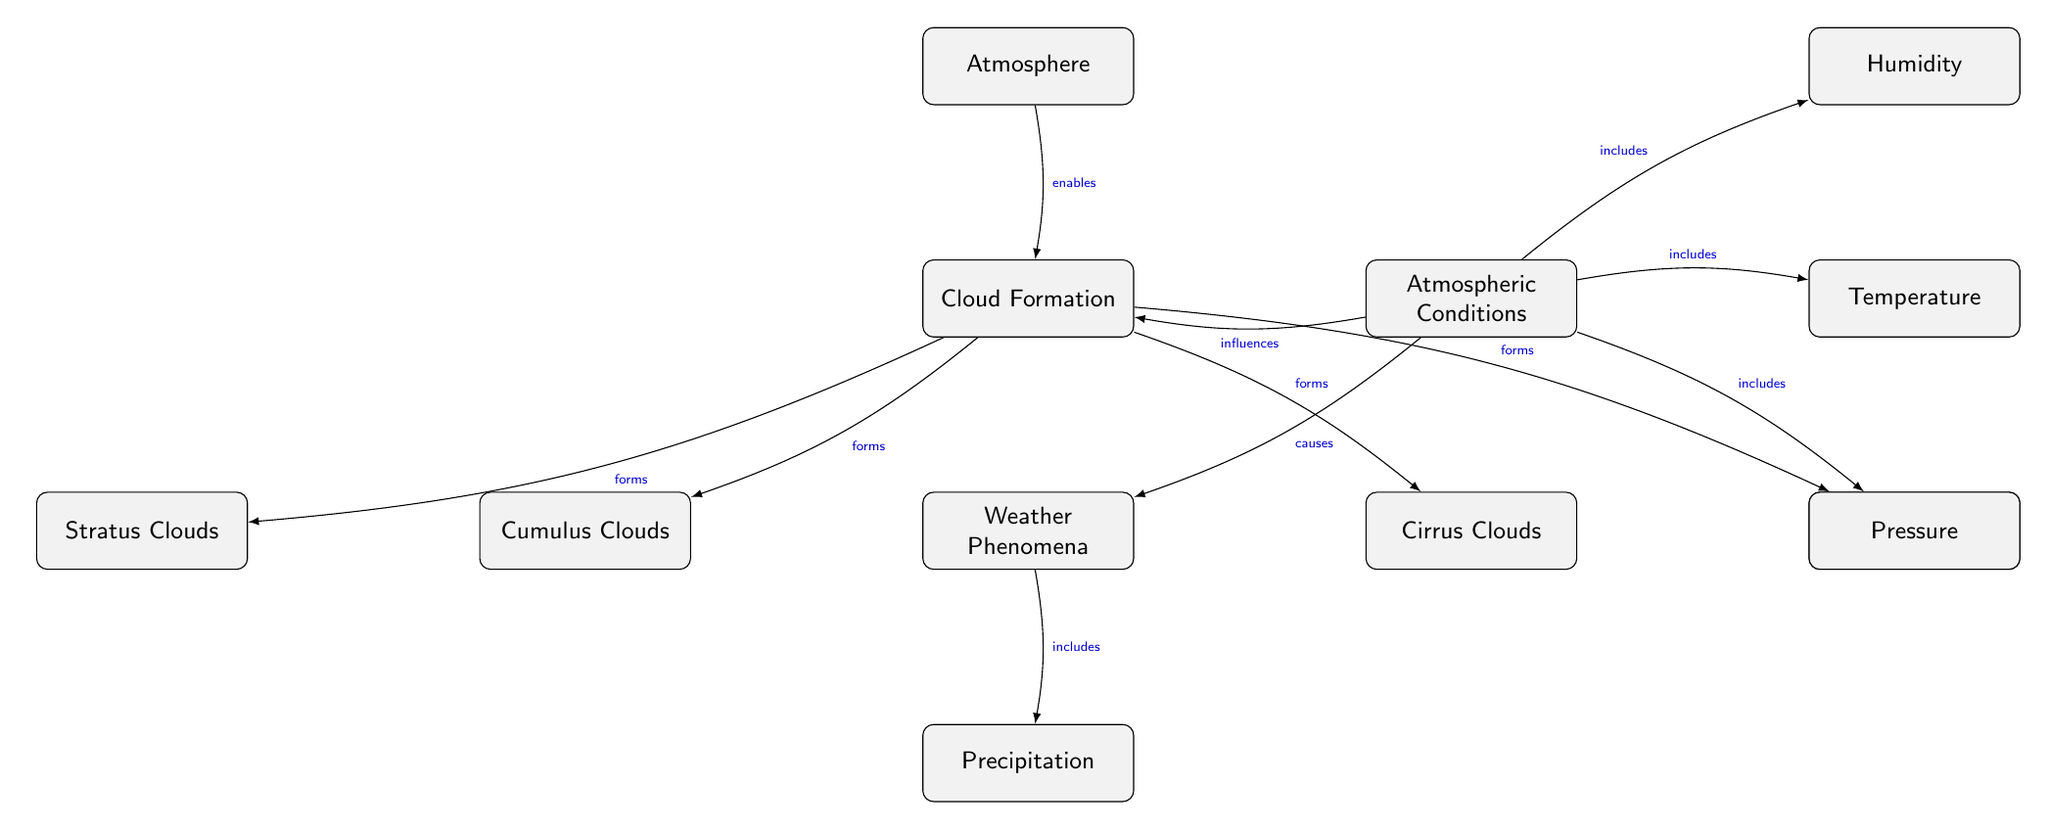What are the types of clouds formed? According to the diagram, the types of clouds formed under Cloud Formation are Cumulus Clouds, Stratus Clouds, Cirrus Clouds, and Nimbus Clouds.
Answer: Cumulus Clouds, Stratus Clouds, Cirrus Clouds, Nimbus Clouds What influences cloud formation? The diagram indicates that Atmospheric Conditions influence Cloud Formation.
Answer: Atmospheric Conditions How many types of clouds are listed? In total, there are four types of clouds listed: Cumulus, Stratus, Cirrus, and Nimbus.
Answer: Four Which phenomenon is included under Weather Phenomena? The diagram specifies that Precipitation is included under Weather Phenomena.
Answer: Precipitation What does Atmospheric Conditions include? According to the diagram, Atmospheric Conditions includes Humidity, Temperature, and Pressure.
Answer: Humidity, Temperature, Pressure What causes Weather Phenomena? The diagram shows that Atmospheric Conditions causes Weather Phenomena.
Answer: Atmospheric Conditions What enables Cloud Formation? The diagram states that the Atmosphere enables Cloud Formation.
Answer: Atmosphere Which type of clouds is directly linked to the Weather Phenomena? The diagram connects Precipitation directly to Weather Phenomena.
Answer: Precipitation How many edges are connecting node Atmospheric Conditions? The diagram has four edges connecting node Atmospheric Conditions to other nodes (Humidity, Temperature, Pressure, and influencing Cloud Formation).
Answer: Four 